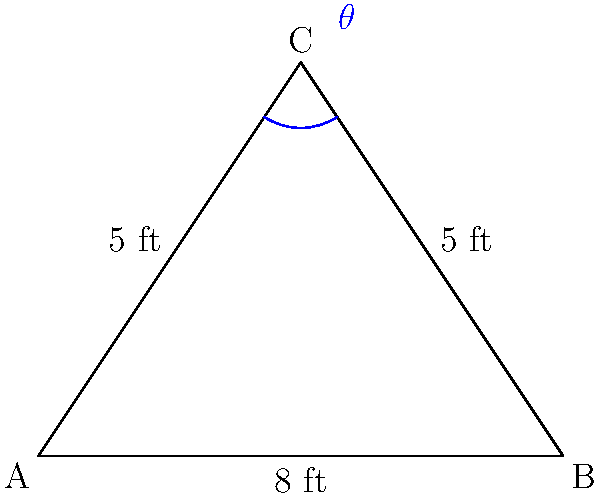In your pawn shop, you've mounted two historical swords on the wall, forming a triangle. The swords are both 5 feet long, and their tips are 8 feet apart. What is the angle $\theta$ (in degrees) between the two swords? Let's approach this step-by-step using the law of cosines:

1) We have an isosceles triangle where two sides (the swords) are equal in length.

2) Let's denote the angle between the swords as $\theta$, and the length of each sword as $a = 5$ ft.

3) The distance between the tips of the swords is $b = 8$ ft.

4) The law of cosines states: $b^2 = a^2 + a^2 - 2a^2 \cos(\theta)$

5) Substituting our values:
   $8^2 = 5^2 + 5^2 - 2(5^2) \cos(\theta)$

6) Simplify:
   $64 = 25 + 25 - 50 \cos(\theta)$
   $64 = 50 - 50 \cos(\theta)$

7) Subtract 50 from both sides:
   $14 = -50 \cos(\theta)$

8) Divide both sides by -50:
   $-0.28 = \cos(\theta)$

9) Take the inverse cosine (arccos) of both sides:
   $\theta = \arccos(-0.28)$

10) Calculate:
    $\theta \approx 106.26°$

Therefore, the angle between the two swords is approximately 106.26 degrees.
Answer: $106.26°$ 